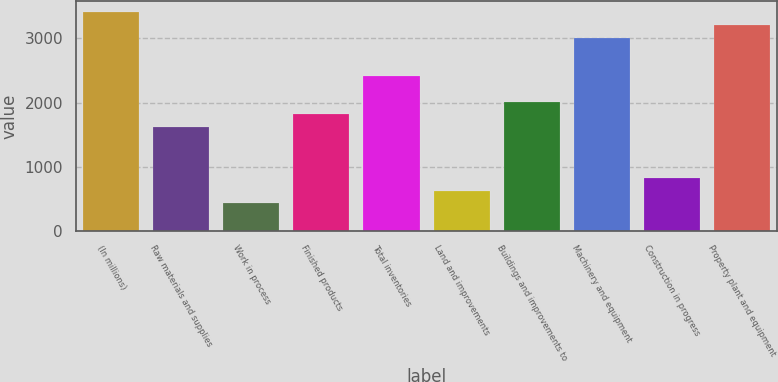Convert chart to OTSL. <chart><loc_0><loc_0><loc_500><loc_500><bar_chart><fcel>(In millions)<fcel>Raw materials and supplies<fcel>Work in process<fcel>Finished products<fcel>Total inventories<fcel>Land and improvements<fcel>Buildings and improvements to<fcel>Machinery and equipment<fcel>Construction in progress<fcel>Property plant and equipment<nl><fcel>3407.88<fcel>1618.32<fcel>425.28<fcel>1817.16<fcel>2413.68<fcel>624.12<fcel>2016<fcel>3010.2<fcel>822.96<fcel>3209.04<nl></chart> 